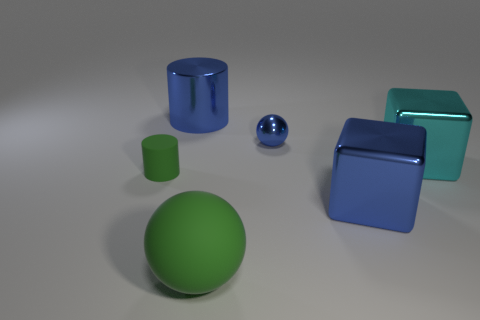Add 2 big yellow shiny cubes. How many objects exist? 8 Subtract all cylinders. How many objects are left? 4 Add 6 small things. How many small things are left? 8 Add 6 cyan cylinders. How many cyan cylinders exist? 6 Subtract 0 gray blocks. How many objects are left? 6 Subtract all small rubber things. Subtract all spheres. How many objects are left? 3 